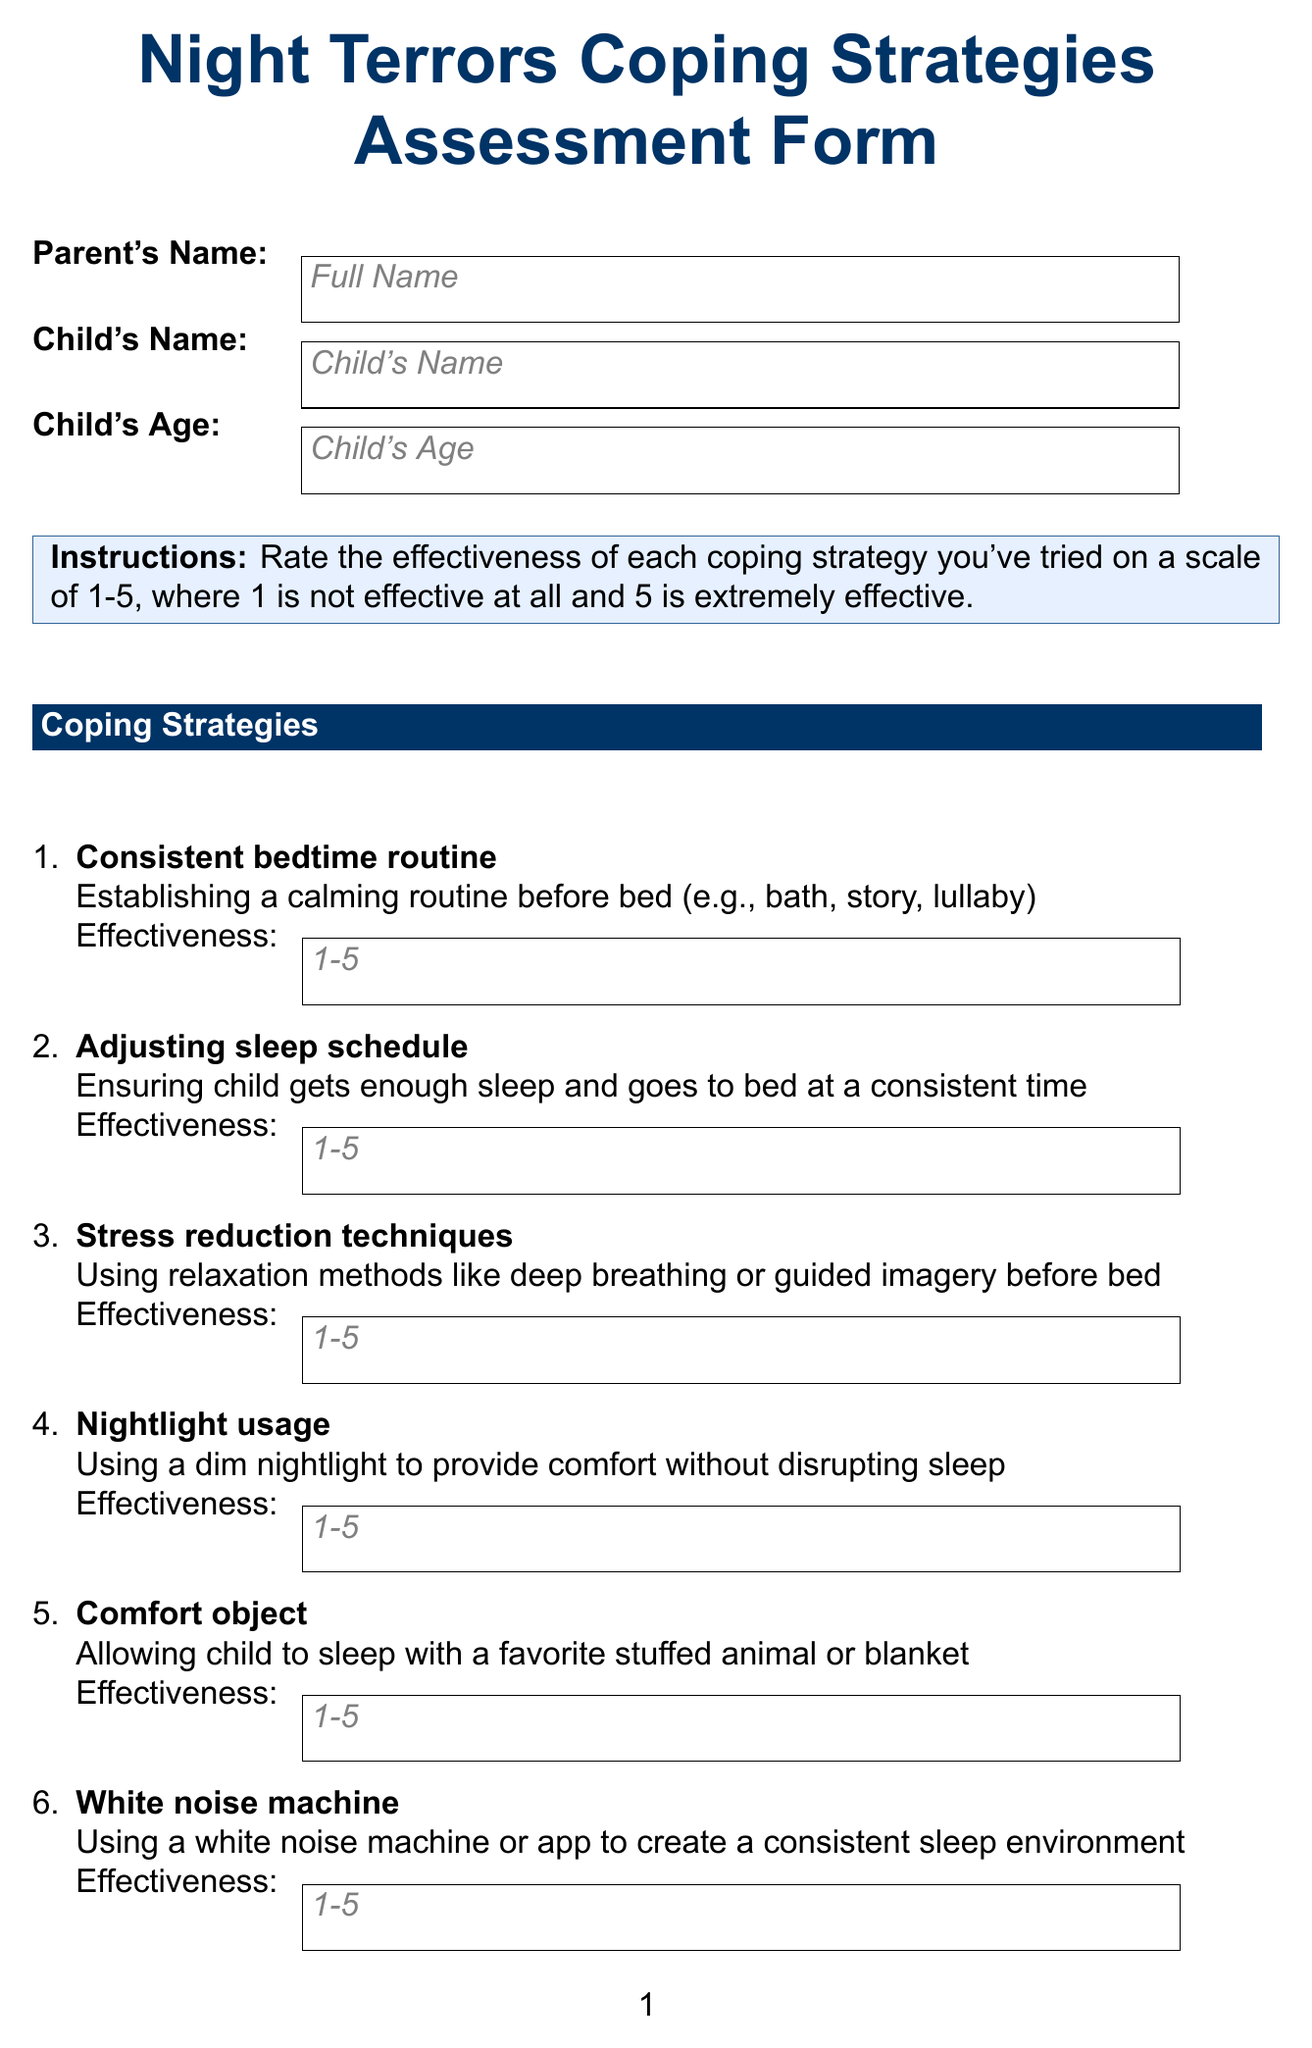What is the title of the form? The title of the form is specified at the beginning of the document.
Answer: Night Terrors Coping Strategies Assessment Form What is the effectiveness rating scale used in the form? The effectiveness rating scale is mentioned in the instructions section of the document.
Answer: 1-5 What should parents provide for their child's age? The parent's information section asks for the child's age.
Answer: Child's Age Name one coping strategy listed in the document. The coping strategies are listed under the coping strategies section.
Answer: Consistent bedtime routine How many additional questions are there in the form? The number of additional questions can be counted from the additional questions section.
Answer: Four What is the suggested room temperature for the child’s sleep environment? The room temperature adjustment strategy discusses the ideal temperature.
Answer: 65-70°F What type of object can be allowed for the child to sleep with? The coping strategies detail the options for comfort objects.
Answer: Stuffed animal or blanket Who should the pediatrician's name be filled out by? The follow-up information section specifies who the pediatrician's name should relate to.
Answer: Parent How is a child's overall sleep quality to be assessed? The question about sleep quality asks for a rating scale for parents to fill out.
Answer: 1-10 